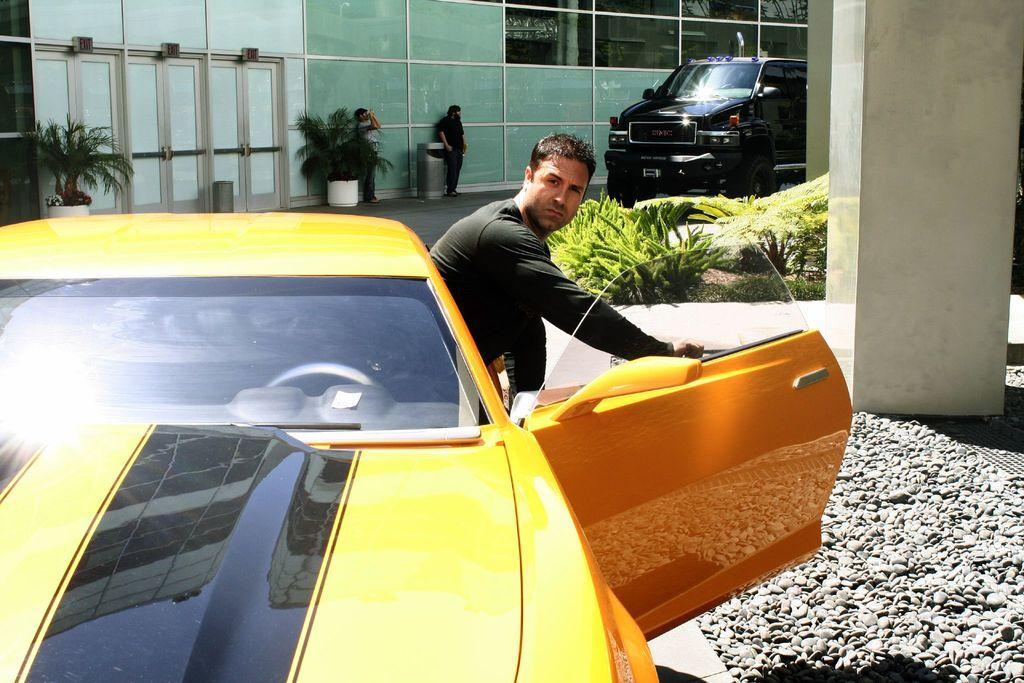How many people are present in the image? There are three people in the image. What is one person doing in the image? One person is coming out from a car. What can be seen in the background of the image? There is a building and a glass door in the background of the image. What object is on the floor in the image? There is a flower pot on the floor. What emotion is the person in the car showing in the image? The provided facts do not mention any emotions or facial expressions of the people in the image, so it cannot be determined from the image. 